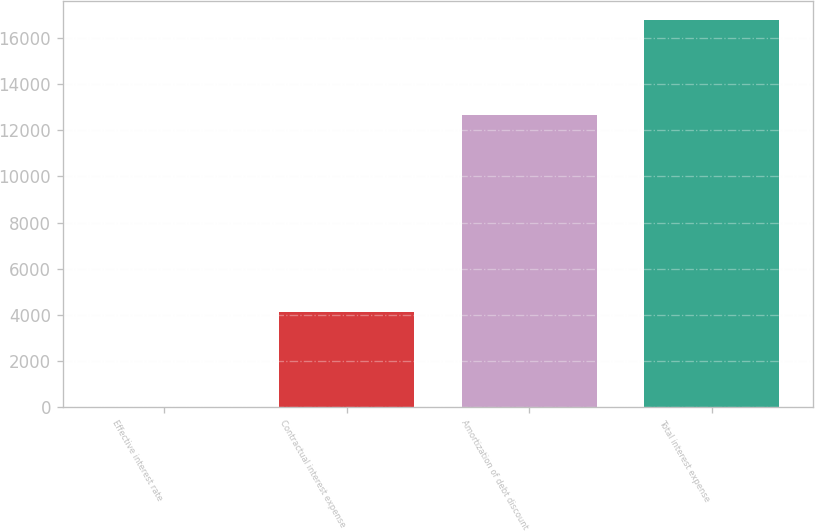Convert chart to OTSL. <chart><loc_0><loc_0><loc_500><loc_500><bar_chart><fcel>Effective interest rate<fcel>Contractual interest expense<fcel>Amortization of debt discount<fcel>Total interest expense<nl><fcel>6.3<fcel>4119<fcel>12654<fcel>16773<nl></chart> 